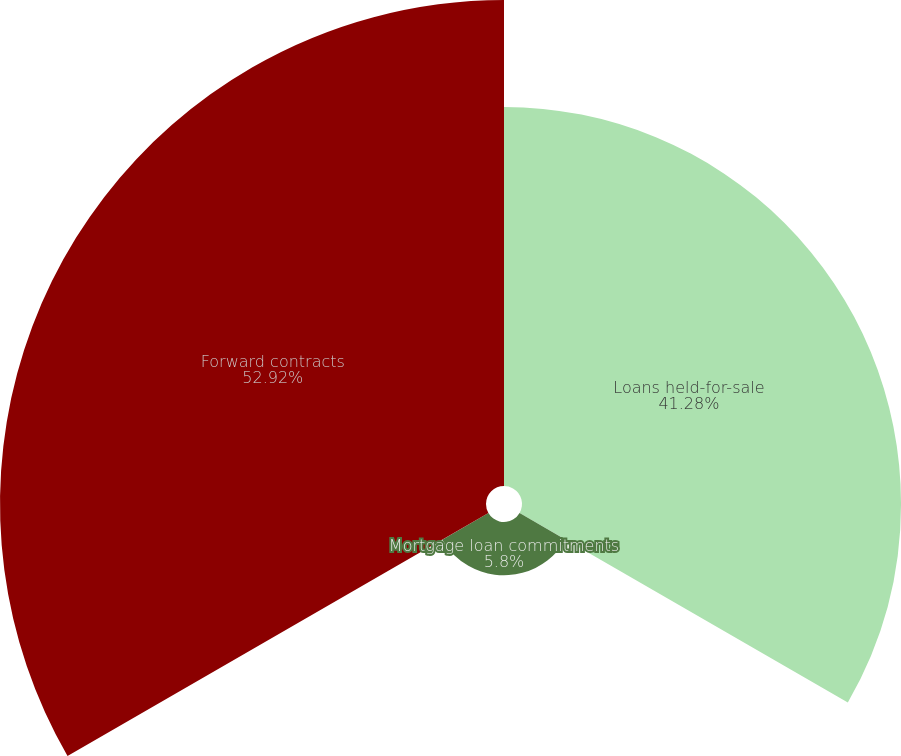Convert chart to OTSL. <chart><loc_0><loc_0><loc_500><loc_500><pie_chart><fcel>Loans held-for-sale<fcel>Mortgage loan commitments<fcel>Forward contracts<nl><fcel>41.28%<fcel>5.8%<fcel>52.93%<nl></chart> 